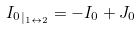<formula> <loc_0><loc_0><loc_500><loc_500>& { I _ { 0 } } _ { | _ { 1 \leftrightarrow 2 } } = - I _ { 0 } + J _ { 0 } &</formula> 